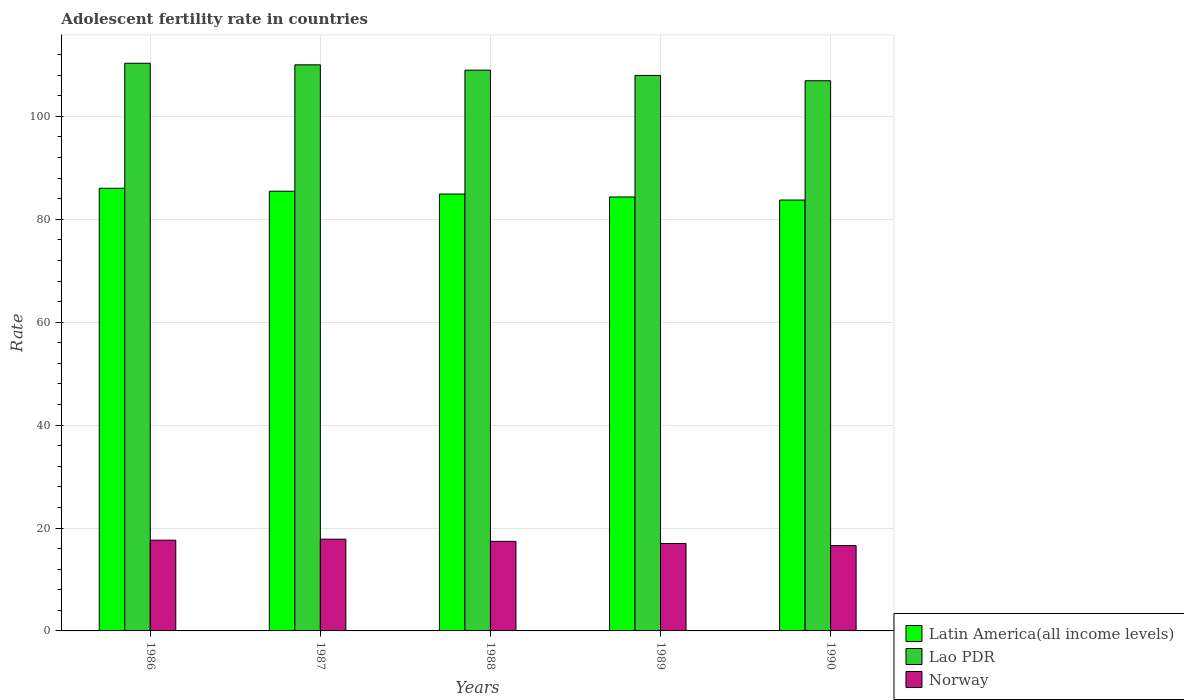How many groups of bars are there?
Your answer should be compact. 5. How many bars are there on the 3rd tick from the left?
Offer a terse response. 3. How many bars are there on the 5th tick from the right?
Keep it short and to the point. 3. What is the label of the 2nd group of bars from the left?
Ensure brevity in your answer.  1987. What is the adolescent fertility rate in Norway in 1990?
Ensure brevity in your answer.  16.58. Across all years, what is the maximum adolescent fertility rate in Norway?
Your response must be concise. 17.83. Across all years, what is the minimum adolescent fertility rate in Norway?
Your response must be concise. 16.58. In which year was the adolescent fertility rate in Norway maximum?
Provide a short and direct response. 1987. What is the total adolescent fertility rate in Latin America(all income levels) in the graph?
Make the answer very short. 424.49. What is the difference between the adolescent fertility rate in Norway in 1987 and that in 1989?
Ensure brevity in your answer.  0.83. What is the difference between the adolescent fertility rate in Latin America(all income levels) in 1988 and the adolescent fertility rate in Norway in 1986?
Provide a succinct answer. 67.28. What is the average adolescent fertility rate in Norway per year?
Give a very brief answer. 17.29. In the year 1986, what is the difference between the adolescent fertility rate in Latin America(all income levels) and adolescent fertility rate in Norway?
Give a very brief answer. 68.4. What is the ratio of the adolescent fertility rate in Latin America(all income levels) in 1986 to that in 1987?
Offer a very short reply. 1.01. Is the difference between the adolescent fertility rate in Latin America(all income levels) in 1986 and 1987 greater than the difference between the adolescent fertility rate in Norway in 1986 and 1987?
Give a very brief answer. Yes. What is the difference between the highest and the second highest adolescent fertility rate in Latin America(all income levels)?
Keep it short and to the point. 0.58. What is the difference between the highest and the lowest adolescent fertility rate in Latin America(all income levels)?
Your answer should be compact. 2.29. What does the 1st bar from the left in 1989 represents?
Your response must be concise. Latin America(all income levels). What does the 3rd bar from the right in 1988 represents?
Your response must be concise. Latin America(all income levels). Is it the case that in every year, the sum of the adolescent fertility rate in Lao PDR and adolescent fertility rate in Latin America(all income levels) is greater than the adolescent fertility rate in Norway?
Make the answer very short. Yes. Are all the bars in the graph horizontal?
Provide a succinct answer. No. Are the values on the major ticks of Y-axis written in scientific E-notation?
Give a very brief answer. No. Does the graph contain any zero values?
Keep it short and to the point. No. Where does the legend appear in the graph?
Your response must be concise. Bottom right. What is the title of the graph?
Offer a terse response. Adolescent fertility rate in countries. What is the label or title of the Y-axis?
Provide a short and direct response. Rate. What is the Rate in Latin America(all income levels) in 1986?
Offer a terse response. 86.03. What is the Rate of Lao PDR in 1986?
Your answer should be compact. 110.33. What is the Rate of Norway in 1986?
Provide a succinct answer. 17.64. What is the Rate of Latin America(all income levels) in 1987?
Give a very brief answer. 85.46. What is the Rate of Lao PDR in 1987?
Provide a short and direct response. 110.02. What is the Rate of Norway in 1987?
Your response must be concise. 17.83. What is the Rate in Latin America(all income levels) in 1988?
Keep it short and to the point. 84.91. What is the Rate in Lao PDR in 1988?
Provide a succinct answer. 108.99. What is the Rate of Norway in 1988?
Ensure brevity in your answer.  17.41. What is the Rate in Latin America(all income levels) in 1989?
Ensure brevity in your answer.  84.34. What is the Rate in Lao PDR in 1989?
Your answer should be compact. 107.96. What is the Rate in Norway in 1989?
Ensure brevity in your answer.  17. What is the Rate in Latin America(all income levels) in 1990?
Ensure brevity in your answer.  83.74. What is the Rate of Lao PDR in 1990?
Offer a very short reply. 106.93. What is the Rate of Norway in 1990?
Ensure brevity in your answer.  16.58. Across all years, what is the maximum Rate in Latin America(all income levels)?
Your answer should be very brief. 86.03. Across all years, what is the maximum Rate of Lao PDR?
Offer a terse response. 110.33. Across all years, what is the maximum Rate of Norway?
Your answer should be very brief. 17.83. Across all years, what is the minimum Rate in Latin America(all income levels)?
Ensure brevity in your answer.  83.74. Across all years, what is the minimum Rate of Lao PDR?
Ensure brevity in your answer.  106.93. Across all years, what is the minimum Rate in Norway?
Your answer should be compact. 16.58. What is the total Rate of Latin America(all income levels) in the graph?
Provide a succinct answer. 424.49. What is the total Rate of Lao PDR in the graph?
Provide a succinct answer. 544.22. What is the total Rate in Norway in the graph?
Ensure brevity in your answer.  86.45. What is the difference between the Rate in Latin America(all income levels) in 1986 and that in 1987?
Keep it short and to the point. 0.57. What is the difference between the Rate in Lao PDR in 1986 and that in 1987?
Offer a very short reply. 0.31. What is the difference between the Rate in Norway in 1986 and that in 1987?
Offer a very short reply. -0.19. What is the difference between the Rate in Latin America(all income levels) in 1986 and that in 1988?
Provide a succinct answer. 1.12. What is the difference between the Rate of Lao PDR in 1986 and that in 1988?
Give a very brief answer. 1.34. What is the difference between the Rate in Norway in 1986 and that in 1988?
Keep it short and to the point. 0.23. What is the difference between the Rate in Latin America(all income levels) in 1986 and that in 1989?
Provide a succinct answer. 1.7. What is the difference between the Rate of Lao PDR in 1986 and that in 1989?
Make the answer very short. 2.37. What is the difference between the Rate of Norway in 1986 and that in 1989?
Offer a terse response. 0.64. What is the difference between the Rate of Latin America(all income levels) in 1986 and that in 1990?
Your response must be concise. 2.29. What is the difference between the Rate in Lao PDR in 1986 and that in 1990?
Provide a succinct answer. 3.4. What is the difference between the Rate in Norway in 1986 and that in 1990?
Your answer should be compact. 1.06. What is the difference between the Rate of Latin America(all income levels) in 1987 and that in 1988?
Offer a terse response. 0.55. What is the difference between the Rate of Lao PDR in 1987 and that in 1988?
Make the answer very short. 1.03. What is the difference between the Rate in Norway in 1987 and that in 1988?
Your answer should be very brief. 0.42. What is the difference between the Rate of Latin America(all income levels) in 1987 and that in 1989?
Provide a short and direct response. 1.12. What is the difference between the Rate in Lao PDR in 1987 and that in 1989?
Offer a terse response. 2.06. What is the difference between the Rate in Norway in 1987 and that in 1989?
Make the answer very short. 0.83. What is the difference between the Rate of Latin America(all income levels) in 1987 and that in 1990?
Your answer should be very brief. 1.71. What is the difference between the Rate in Lao PDR in 1987 and that in 1990?
Your response must be concise. 3.09. What is the difference between the Rate in Norway in 1987 and that in 1990?
Make the answer very short. 1.25. What is the difference between the Rate of Latin America(all income levels) in 1988 and that in 1989?
Your response must be concise. 0.57. What is the difference between the Rate of Lao PDR in 1988 and that in 1989?
Provide a short and direct response. 1.03. What is the difference between the Rate of Norway in 1988 and that in 1989?
Provide a succinct answer. 0.42. What is the difference between the Rate in Latin America(all income levels) in 1988 and that in 1990?
Your answer should be compact. 1.17. What is the difference between the Rate of Lao PDR in 1988 and that in 1990?
Your response must be concise. 2.06. What is the difference between the Rate of Norway in 1988 and that in 1990?
Offer a very short reply. 0.83. What is the difference between the Rate of Latin America(all income levels) in 1989 and that in 1990?
Give a very brief answer. 0.59. What is the difference between the Rate in Lao PDR in 1989 and that in 1990?
Make the answer very short. 1.03. What is the difference between the Rate in Norway in 1989 and that in 1990?
Your response must be concise. 0.42. What is the difference between the Rate of Latin America(all income levels) in 1986 and the Rate of Lao PDR in 1987?
Ensure brevity in your answer.  -23.99. What is the difference between the Rate of Latin America(all income levels) in 1986 and the Rate of Norway in 1987?
Provide a succinct answer. 68.21. What is the difference between the Rate of Lao PDR in 1986 and the Rate of Norway in 1987?
Give a very brief answer. 92.5. What is the difference between the Rate in Latin America(all income levels) in 1986 and the Rate in Lao PDR in 1988?
Make the answer very short. -22.95. What is the difference between the Rate in Latin America(all income levels) in 1986 and the Rate in Norway in 1988?
Ensure brevity in your answer.  68.62. What is the difference between the Rate in Lao PDR in 1986 and the Rate in Norway in 1988?
Offer a very short reply. 92.92. What is the difference between the Rate of Latin America(all income levels) in 1986 and the Rate of Lao PDR in 1989?
Make the answer very short. -21.92. What is the difference between the Rate in Latin America(all income levels) in 1986 and the Rate in Norway in 1989?
Offer a terse response. 69.04. What is the difference between the Rate in Lao PDR in 1986 and the Rate in Norway in 1989?
Give a very brief answer. 93.33. What is the difference between the Rate in Latin America(all income levels) in 1986 and the Rate in Lao PDR in 1990?
Ensure brevity in your answer.  -20.89. What is the difference between the Rate in Latin America(all income levels) in 1986 and the Rate in Norway in 1990?
Offer a very short reply. 69.45. What is the difference between the Rate in Lao PDR in 1986 and the Rate in Norway in 1990?
Keep it short and to the point. 93.75. What is the difference between the Rate in Latin America(all income levels) in 1987 and the Rate in Lao PDR in 1988?
Your answer should be very brief. -23.53. What is the difference between the Rate in Latin America(all income levels) in 1987 and the Rate in Norway in 1988?
Offer a terse response. 68.05. What is the difference between the Rate in Lao PDR in 1987 and the Rate in Norway in 1988?
Your answer should be compact. 92.61. What is the difference between the Rate in Latin America(all income levels) in 1987 and the Rate in Lao PDR in 1989?
Your response must be concise. -22.5. What is the difference between the Rate in Latin America(all income levels) in 1987 and the Rate in Norway in 1989?
Provide a succinct answer. 68.46. What is the difference between the Rate in Lao PDR in 1987 and the Rate in Norway in 1989?
Provide a short and direct response. 93.02. What is the difference between the Rate in Latin America(all income levels) in 1987 and the Rate in Lao PDR in 1990?
Your response must be concise. -21.47. What is the difference between the Rate in Latin America(all income levels) in 1987 and the Rate in Norway in 1990?
Your answer should be very brief. 68.88. What is the difference between the Rate of Lao PDR in 1987 and the Rate of Norway in 1990?
Give a very brief answer. 93.44. What is the difference between the Rate of Latin America(all income levels) in 1988 and the Rate of Lao PDR in 1989?
Provide a short and direct response. -23.04. What is the difference between the Rate in Latin America(all income levels) in 1988 and the Rate in Norway in 1989?
Offer a very short reply. 67.92. What is the difference between the Rate in Lao PDR in 1988 and the Rate in Norway in 1989?
Ensure brevity in your answer.  91.99. What is the difference between the Rate in Latin America(all income levels) in 1988 and the Rate in Lao PDR in 1990?
Make the answer very short. -22.01. What is the difference between the Rate in Latin America(all income levels) in 1988 and the Rate in Norway in 1990?
Provide a short and direct response. 68.33. What is the difference between the Rate in Lao PDR in 1988 and the Rate in Norway in 1990?
Keep it short and to the point. 92.41. What is the difference between the Rate of Latin America(all income levels) in 1989 and the Rate of Lao PDR in 1990?
Your response must be concise. -22.59. What is the difference between the Rate in Latin America(all income levels) in 1989 and the Rate in Norway in 1990?
Your answer should be compact. 67.76. What is the difference between the Rate in Lao PDR in 1989 and the Rate in Norway in 1990?
Keep it short and to the point. 91.38. What is the average Rate of Latin America(all income levels) per year?
Give a very brief answer. 84.9. What is the average Rate of Lao PDR per year?
Offer a very short reply. 108.84. What is the average Rate in Norway per year?
Your answer should be very brief. 17.29. In the year 1986, what is the difference between the Rate of Latin America(all income levels) and Rate of Lao PDR?
Your response must be concise. -24.29. In the year 1986, what is the difference between the Rate of Latin America(all income levels) and Rate of Norway?
Make the answer very short. 68.4. In the year 1986, what is the difference between the Rate in Lao PDR and Rate in Norway?
Provide a short and direct response. 92.69. In the year 1987, what is the difference between the Rate of Latin America(all income levels) and Rate of Lao PDR?
Offer a terse response. -24.56. In the year 1987, what is the difference between the Rate in Latin America(all income levels) and Rate in Norway?
Make the answer very short. 67.63. In the year 1987, what is the difference between the Rate in Lao PDR and Rate in Norway?
Your answer should be very brief. 92.19. In the year 1988, what is the difference between the Rate in Latin America(all income levels) and Rate in Lao PDR?
Your response must be concise. -24.08. In the year 1988, what is the difference between the Rate in Latin America(all income levels) and Rate in Norway?
Your response must be concise. 67.5. In the year 1988, what is the difference between the Rate of Lao PDR and Rate of Norway?
Keep it short and to the point. 91.58. In the year 1989, what is the difference between the Rate in Latin America(all income levels) and Rate in Lao PDR?
Your answer should be compact. -23.62. In the year 1989, what is the difference between the Rate in Latin America(all income levels) and Rate in Norway?
Give a very brief answer. 67.34. In the year 1989, what is the difference between the Rate of Lao PDR and Rate of Norway?
Ensure brevity in your answer.  90.96. In the year 1990, what is the difference between the Rate in Latin America(all income levels) and Rate in Lao PDR?
Make the answer very short. -23.18. In the year 1990, what is the difference between the Rate of Latin America(all income levels) and Rate of Norway?
Ensure brevity in your answer.  67.17. In the year 1990, what is the difference between the Rate of Lao PDR and Rate of Norway?
Provide a short and direct response. 90.35. What is the ratio of the Rate of Lao PDR in 1986 to that in 1987?
Provide a succinct answer. 1. What is the ratio of the Rate in Norway in 1986 to that in 1987?
Your answer should be very brief. 0.99. What is the ratio of the Rate of Latin America(all income levels) in 1986 to that in 1988?
Offer a terse response. 1.01. What is the ratio of the Rate in Lao PDR in 1986 to that in 1988?
Your answer should be very brief. 1.01. What is the ratio of the Rate of Norway in 1986 to that in 1988?
Your answer should be compact. 1.01. What is the ratio of the Rate of Latin America(all income levels) in 1986 to that in 1989?
Your answer should be compact. 1.02. What is the ratio of the Rate in Lao PDR in 1986 to that in 1989?
Give a very brief answer. 1.02. What is the ratio of the Rate of Norway in 1986 to that in 1989?
Your response must be concise. 1.04. What is the ratio of the Rate of Latin America(all income levels) in 1986 to that in 1990?
Offer a terse response. 1.03. What is the ratio of the Rate of Lao PDR in 1986 to that in 1990?
Your response must be concise. 1.03. What is the ratio of the Rate in Norway in 1986 to that in 1990?
Your answer should be very brief. 1.06. What is the ratio of the Rate of Latin America(all income levels) in 1987 to that in 1988?
Provide a succinct answer. 1.01. What is the ratio of the Rate of Lao PDR in 1987 to that in 1988?
Keep it short and to the point. 1.01. What is the ratio of the Rate in Norway in 1987 to that in 1988?
Your response must be concise. 1.02. What is the ratio of the Rate in Latin America(all income levels) in 1987 to that in 1989?
Your response must be concise. 1.01. What is the ratio of the Rate of Lao PDR in 1987 to that in 1989?
Make the answer very short. 1.02. What is the ratio of the Rate in Norway in 1987 to that in 1989?
Offer a very short reply. 1.05. What is the ratio of the Rate in Latin America(all income levels) in 1987 to that in 1990?
Your answer should be compact. 1.02. What is the ratio of the Rate of Lao PDR in 1987 to that in 1990?
Your answer should be compact. 1.03. What is the ratio of the Rate of Norway in 1987 to that in 1990?
Ensure brevity in your answer.  1.08. What is the ratio of the Rate in Latin America(all income levels) in 1988 to that in 1989?
Make the answer very short. 1.01. What is the ratio of the Rate of Lao PDR in 1988 to that in 1989?
Provide a succinct answer. 1.01. What is the ratio of the Rate of Norway in 1988 to that in 1989?
Your response must be concise. 1.02. What is the ratio of the Rate in Lao PDR in 1988 to that in 1990?
Your answer should be very brief. 1.02. What is the ratio of the Rate of Norway in 1988 to that in 1990?
Your answer should be compact. 1.05. What is the ratio of the Rate in Latin America(all income levels) in 1989 to that in 1990?
Keep it short and to the point. 1.01. What is the ratio of the Rate in Lao PDR in 1989 to that in 1990?
Your answer should be compact. 1.01. What is the ratio of the Rate in Norway in 1989 to that in 1990?
Offer a very short reply. 1.03. What is the difference between the highest and the second highest Rate of Latin America(all income levels)?
Provide a succinct answer. 0.57. What is the difference between the highest and the second highest Rate in Lao PDR?
Ensure brevity in your answer.  0.31. What is the difference between the highest and the second highest Rate of Norway?
Ensure brevity in your answer.  0.19. What is the difference between the highest and the lowest Rate of Latin America(all income levels)?
Your response must be concise. 2.29. What is the difference between the highest and the lowest Rate in Lao PDR?
Make the answer very short. 3.4. What is the difference between the highest and the lowest Rate of Norway?
Make the answer very short. 1.25. 